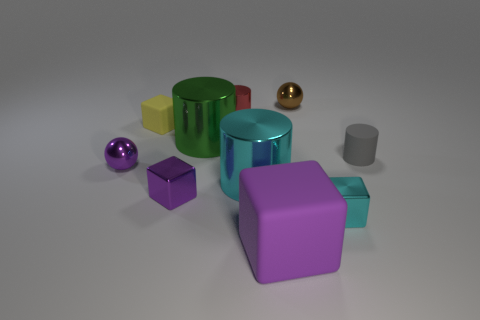There is a purple block that is on the right side of the green metal object; is its size the same as the green metal cylinder?
Ensure brevity in your answer.  Yes. What is the color of the cube that is behind the small cyan metal block and right of the tiny yellow block?
Offer a terse response. Purple. What number of small matte cylinders are in front of the rubber thing to the left of the large purple thing?
Your answer should be very brief. 1. Is the large cyan metallic thing the same shape as the gray rubber object?
Your answer should be very brief. Yes. Is there any other thing that has the same color as the tiny shiny cylinder?
Make the answer very short. No. Do the small red shiny thing and the tiny cyan object that is in front of the small red metallic object have the same shape?
Offer a very short reply. No. The tiny metal block on the left side of the big cylinder behind the cylinder right of the purple matte cube is what color?
Your answer should be very brief. Purple. Are there any other things that have the same material as the small purple sphere?
Your answer should be compact. Yes. There is a small purple thing that is to the left of the small purple metal block; is it the same shape as the small gray thing?
Give a very brief answer. No. What material is the small red cylinder?
Make the answer very short. Metal. 